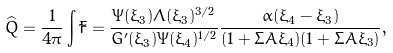Convert formula to latex. <formula><loc_0><loc_0><loc_500><loc_500>\widehat { Q } = \frac { 1 } { 4 \pi } \int \tilde { F } = \frac { \Psi ( \xi _ { 3 } ) \Lambda ( \xi _ { 3 } ) ^ { 3 / 2 } } { G ^ { \prime } ( \xi _ { 3 } ) \Psi ( \xi _ { 4 } ) ^ { 1 / 2 } } \frac { \alpha ( \xi _ { 4 } - \xi _ { 3 } ) } { ( 1 + \Sigma A \xi _ { 4 } ) ( 1 + \Sigma A \xi _ { 3 } ) } ,</formula> 